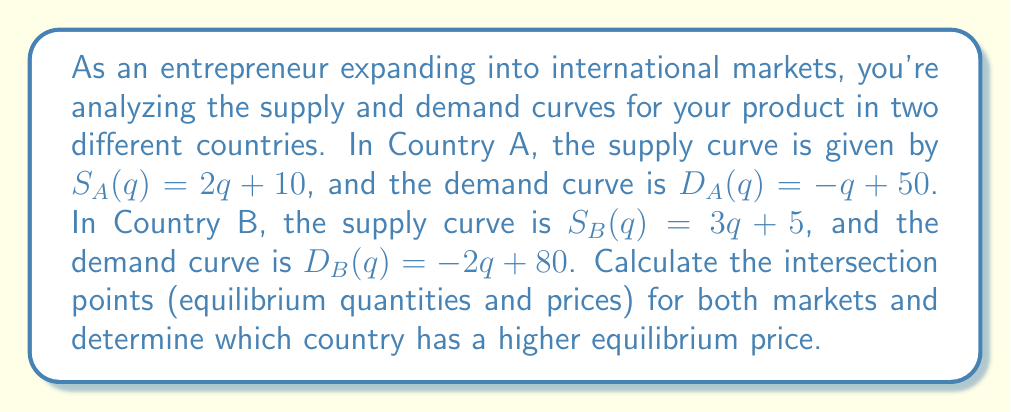Provide a solution to this math problem. Let's solve this problem step by step for each country:

Country A:
1) At equilibrium, supply equals demand: $S_A(q) = D_A(q)$
2) Substitute the equations: $2q + 10 = -q + 50$
3) Solve for q:
   $3q = 40$
   $q_A = \frac{40}{3} \approx 13.33$
4) To find the equilibrium price, substitute $q_A$ into either equation:
   $P_A = 2(\frac{40}{3}) + 10 = \frac{80}{3} + 10 = \frac{110}{3} \approx 36.67$

Country B:
1) At equilibrium, supply equals demand: $S_B(q) = D_B(q)$
2) Substitute the equations: $3q + 5 = -2q + 80$
3) Solve for q:
   $5q = 75$
   $q_B = 15$
4) To find the equilibrium price, substitute $q_B$ into either equation:
   $P_B = 3(15) + 5 = 50$

Comparing equilibrium prices:
Country A: $P_A = \frac{110}{3} \approx 36.67$
Country B: $P_B = 50$

Country B has a higher equilibrium price.
Answer: Country A: $(\frac{40}{3}, \frac{110}{3})$; Country B: $(15, 50)$; Country B has higher price. 